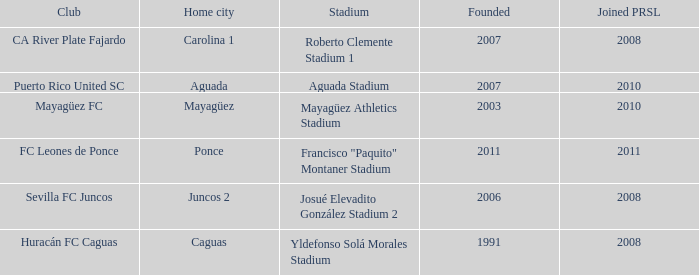What is the club that was founded before 2007, joined prsl in 2008 and the stadium is yldefonso solá morales stadium? Huracán FC Caguas. 